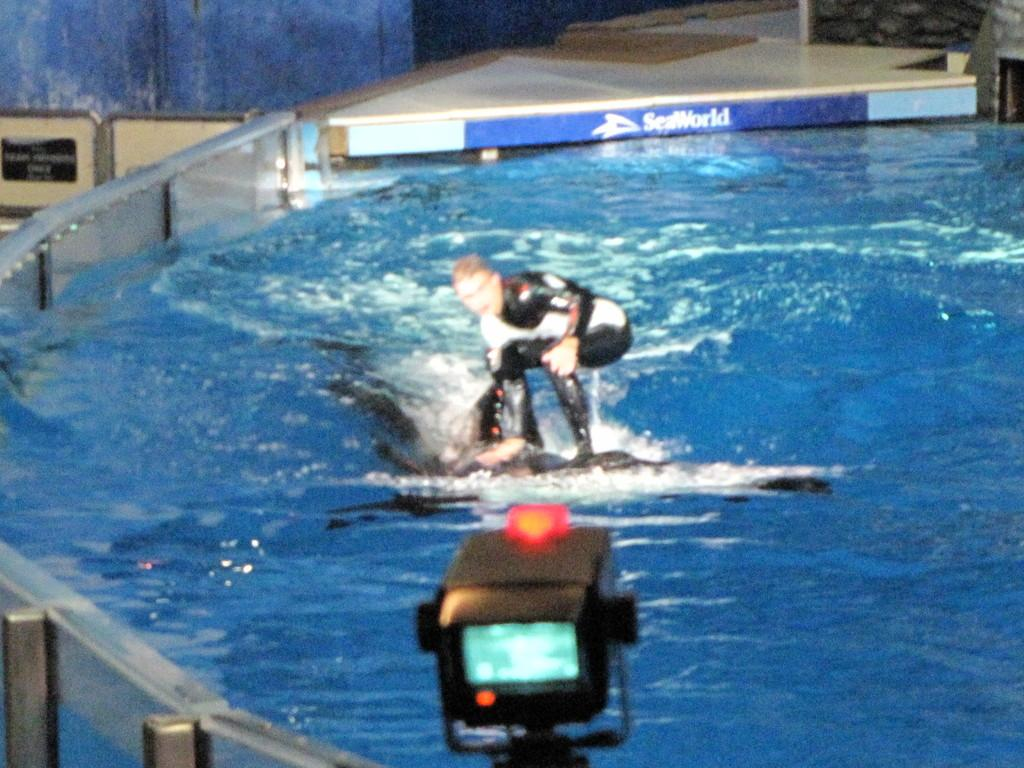Who is present in the image? There is a man in the image. What is the man doing in the image? The man is on an object in the image. What is the location of the object the man is on? The object is on the water. What can be seen on the left side of the image? There is a glass fence on the left side of the image. Where is the camera located in the image? The camera is at the bottom of the image. What type of vegetable is being used as a prop in the image? There is no vegetable present in the image. How many wings can be seen on the man in the image? The man in the image does not have any wings. 